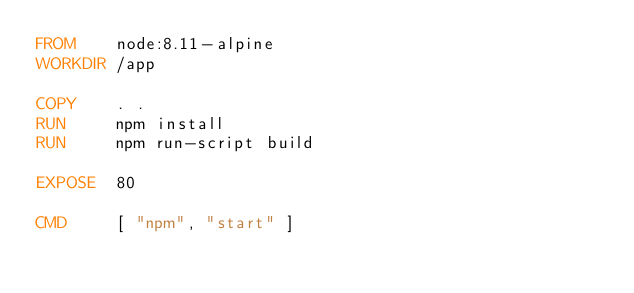Convert code to text. <code><loc_0><loc_0><loc_500><loc_500><_Dockerfile_>FROM    node:8.11-alpine
WORKDIR /app

COPY    . .
RUN     npm install
RUN     npm run-script build

EXPOSE  80

CMD     [ "npm", "start" ]</code> 